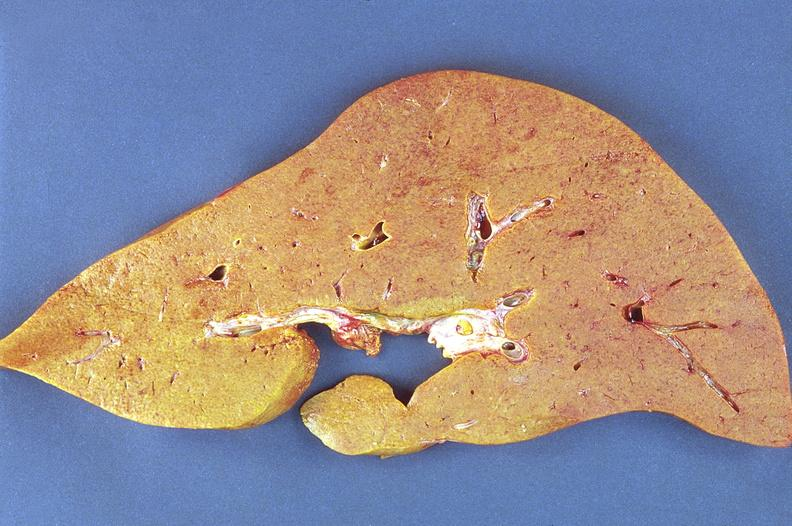what is present?
Answer the question using a single word or phrase. Liver 